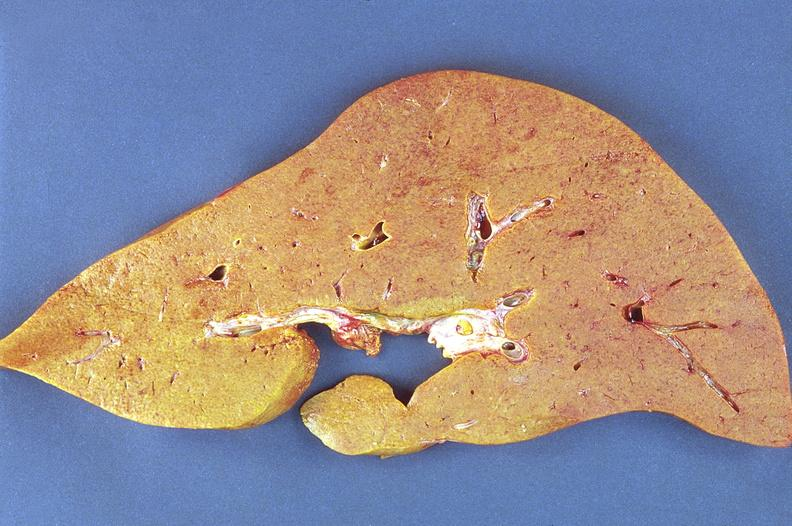what is present?
Answer the question using a single word or phrase. Liver 